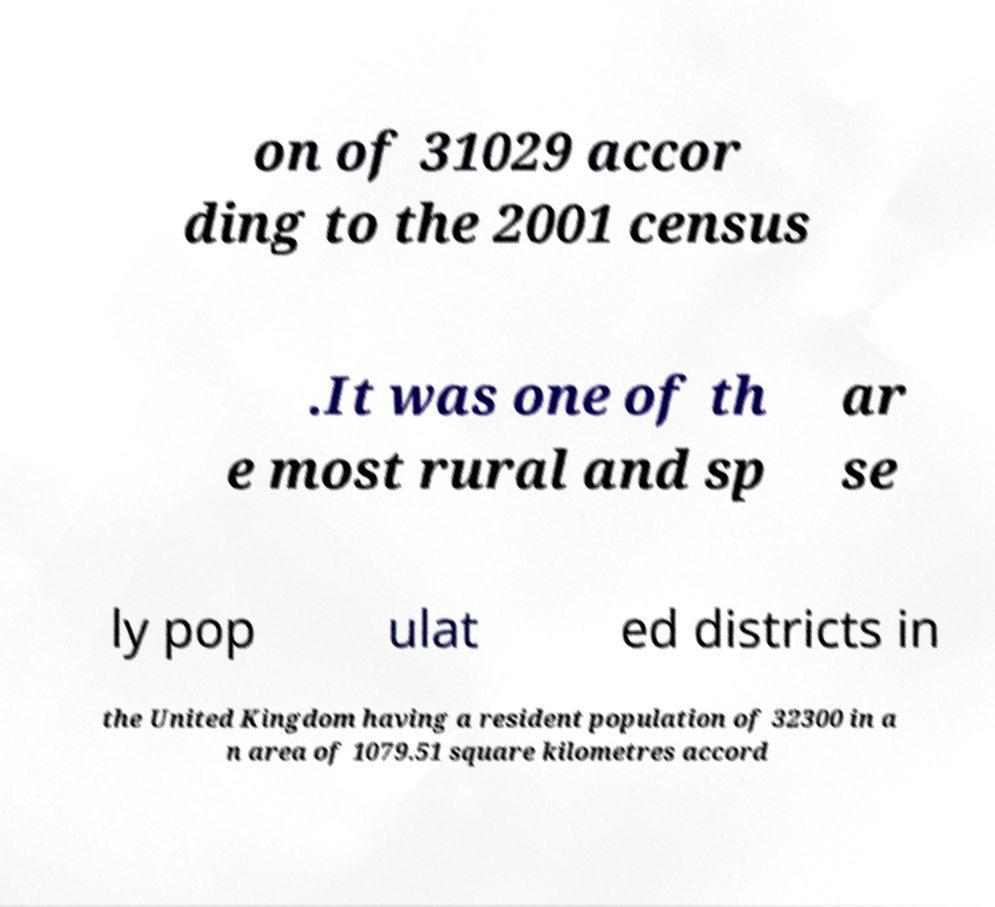Please identify and transcribe the text found in this image. on of 31029 accor ding to the 2001 census .It was one of th e most rural and sp ar se ly pop ulat ed districts in the United Kingdom having a resident population of 32300 in a n area of 1079.51 square kilometres accord 